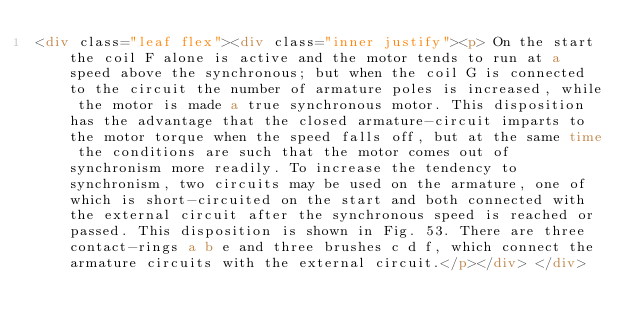<code> <loc_0><loc_0><loc_500><loc_500><_HTML_><div class="leaf flex"><div class="inner justify"><p> On the start the coil F alone is active and the motor tends to run at a speed above the synchronous; but when the coil G is connected to the circuit the number of armature poles is increased, while the motor is made a true synchronous motor. This disposition has the advantage that the closed armature-circuit imparts to the motor torque when the speed falls off, but at the same time the conditions are such that the motor comes out of synchronism more readily. To increase the tendency to synchronism, two circuits may be used on the armature, one of which is short-circuited on the start and both connected with the external circuit after the synchronous speed is reached or passed. This disposition is shown in Fig. 53. There are three contact-rings a b e and three brushes c d f, which connect the armature circuits with the external circuit.</p></div> </div></code> 